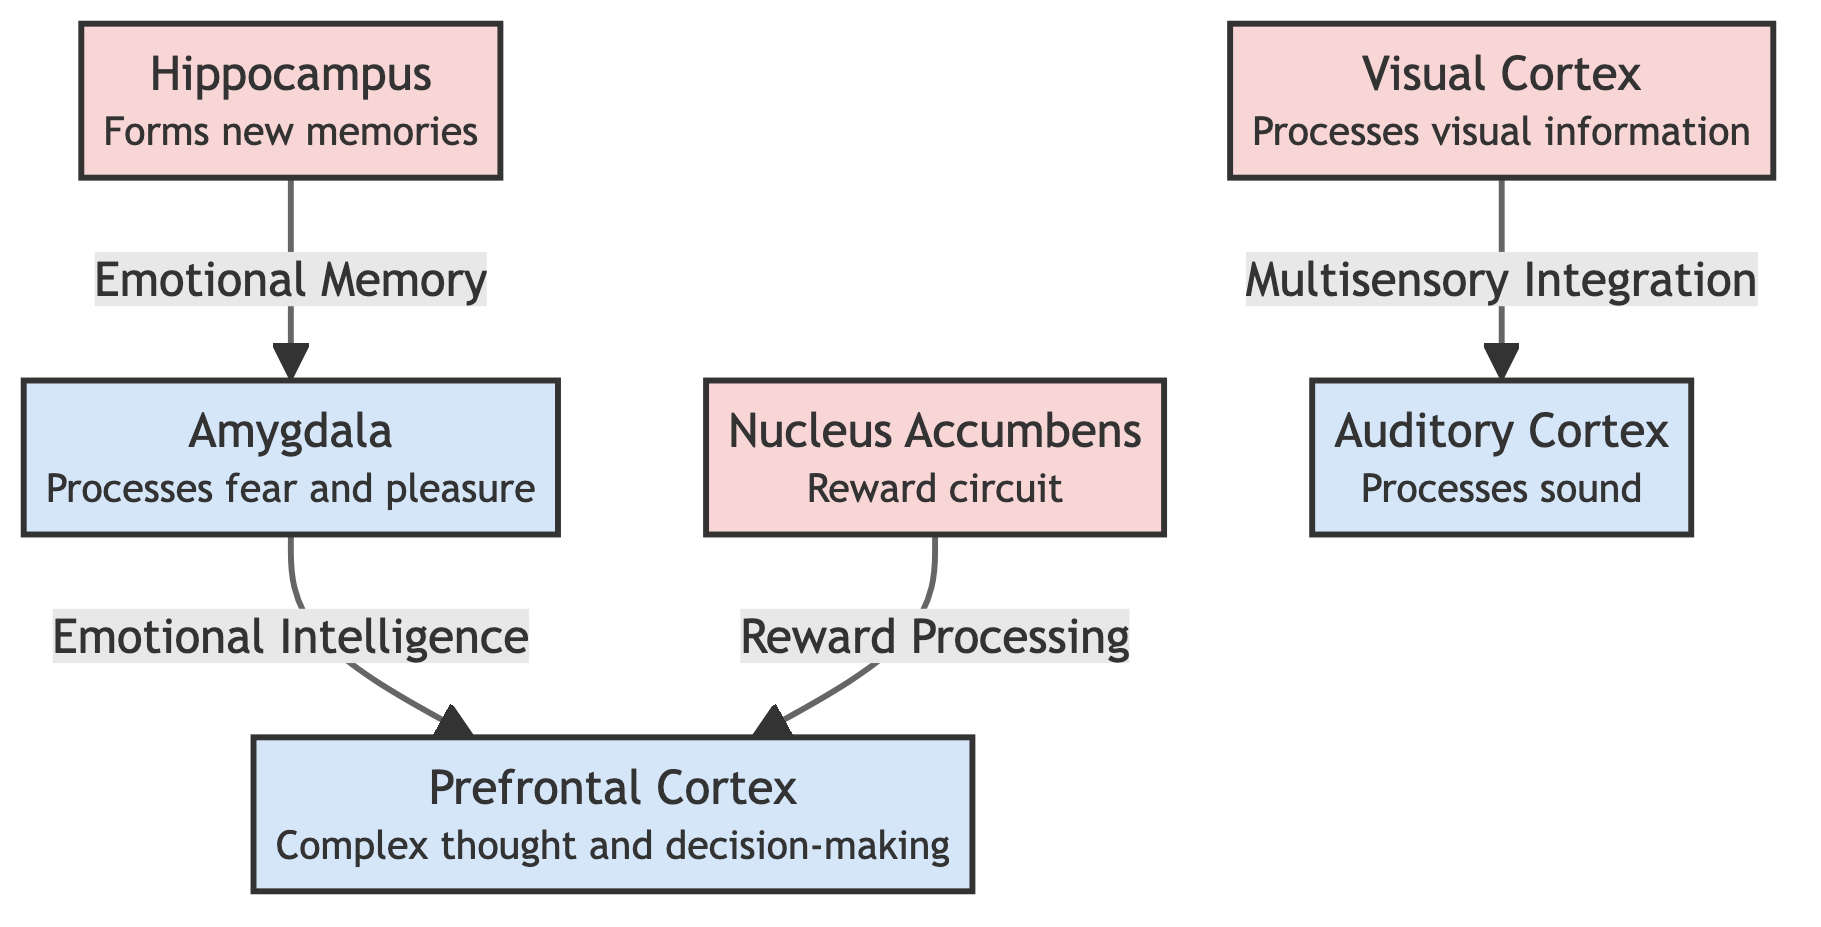What is the function of the amygdala? The amygdala processes both fear and pleasure, as indicated in the diagram by the description attached to the node.
Answer: Processes fear and pleasure How many brain regions are mentioned in the diagram? The diagram includes six nodes representing different brain regions: amygdala, prefrontal cortex, hippocampus, nucleus accumbens, visual cortex, and auditory cortex.
Answer: Six What connects the amygdala to the prefrontal cortex? The relationship between the amygdala and the prefrontal cortex is represented by the label "Emotional Intelligence," indicating how they interact.
Answer: Emotional Intelligence Which brain region is responsible for forming new memories? The diagram specifically labels the hippocampus as the region responsible for forming new memories, making it clear.
Answer: Hippocampus What do the nucleus accumbens and prefrontal cortex have in common? Both the nucleus accumbens and prefrontal cortex are connected by the relationship labeled "Reward Processing," indicating a shared function related to rewards.
Answer: Reward Processing Which two brain regions are connected by "Multisensory Integration"? The visual cortex and auditory cortex are connected through the label "Multisensory Integration," showing how they work together in processing sensory information.
Answer: Visual Cortex and Auditory Cortex How does the hippocampus relate to emotional memory in the diagram? The hippocampus is connected to the amygdala by the label "Emotional Memory," indicating that the formation of memories has a role in emotional processing.
Answer: Emotional Memory What is the role of the auditory cortex according to the diagram? According to the diagram, the auditory cortex processes sound as indicated by the description next to its node.
Answer: Processes sound What links visual and auditory processing according to the diagram? The link between visual and auditory processing is described by "Multisensory Integration," illustrating the connection between these sensory areas.
Answer: Multisensory Integration 